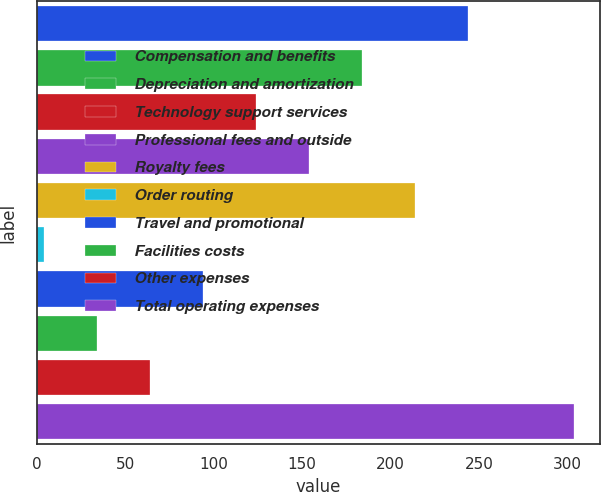<chart> <loc_0><loc_0><loc_500><loc_500><bar_chart><fcel>Compensation and benefits<fcel>Depreciation and amortization<fcel>Technology support services<fcel>Professional fees and outside<fcel>Royalty fees<fcel>Order routing<fcel>Travel and promotional<fcel>Facilities costs<fcel>Other expenses<fcel>Total operating expenses<nl><fcel>243.54<fcel>183.68<fcel>123.82<fcel>153.75<fcel>213.61<fcel>4.1<fcel>93.89<fcel>34.03<fcel>63.96<fcel>303.4<nl></chart> 